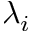<formula> <loc_0><loc_0><loc_500><loc_500>\lambda _ { i }</formula> 